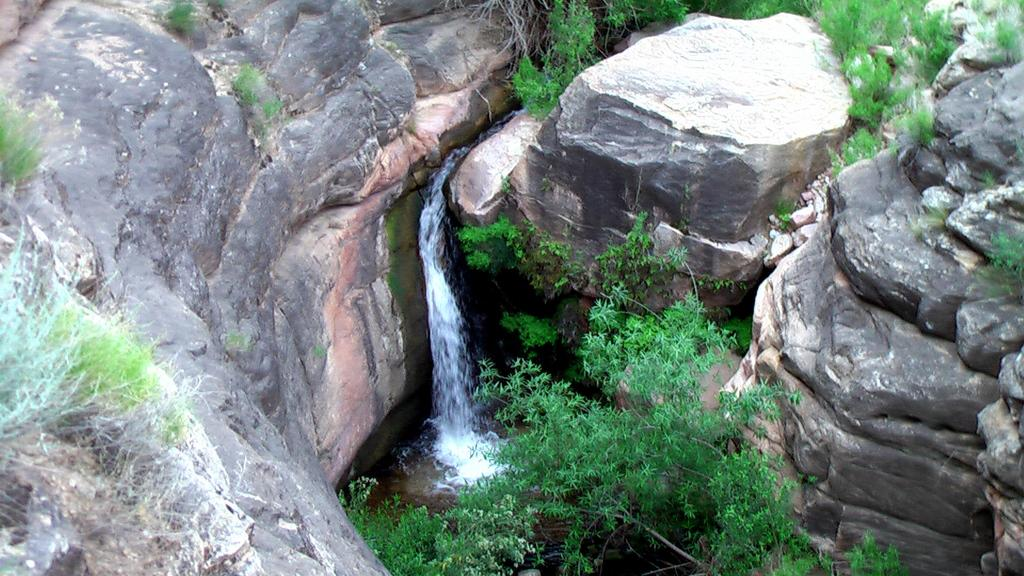What type of vegetation is present in the center of the image? There are trees and grass in the center of the image. What other natural features can be seen in the center of the image? There are hills and water visible in the center of the image. Can you see any popcorn growing on the hills in the image? There is no popcorn present in the image; it is a natural landscape featuring trees, grass, hills, and water. Are there any bears visible in the image? There are no bears present in the image; it is a landscape without any animals depicted. 